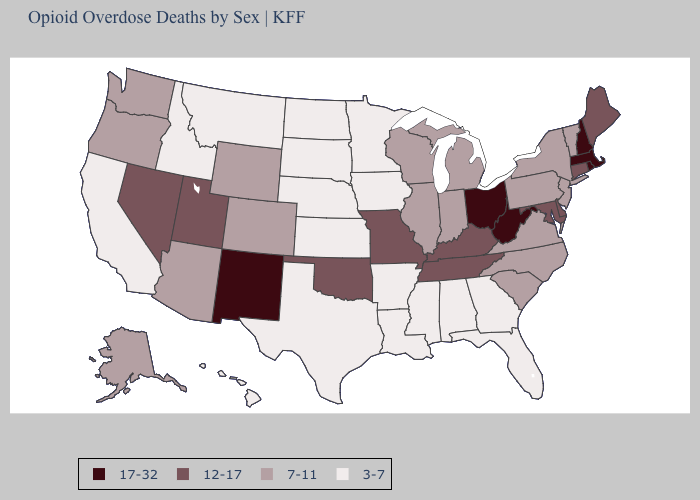Name the states that have a value in the range 17-32?
Write a very short answer. Massachusetts, New Hampshire, New Mexico, Ohio, Rhode Island, West Virginia. Which states have the lowest value in the West?
Be succinct. California, Hawaii, Idaho, Montana. What is the value of Mississippi?
Concise answer only. 3-7. What is the lowest value in states that border Wisconsin?
Keep it brief. 3-7. What is the highest value in the South ?
Write a very short answer. 17-32. Among the states that border Oregon , which have the lowest value?
Keep it brief. California, Idaho. What is the highest value in states that border Delaware?
Short answer required. 12-17. Name the states that have a value in the range 7-11?
Be succinct. Alaska, Arizona, Colorado, Illinois, Indiana, Michigan, New Jersey, New York, North Carolina, Oregon, Pennsylvania, South Carolina, Vermont, Virginia, Washington, Wisconsin, Wyoming. What is the value of Oklahoma?
Keep it brief. 12-17. Does the first symbol in the legend represent the smallest category?
Short answer required. No. Among the states that border Maryland , which have the lowest value?
Answer briefly. Pennsylvania, Virginia. Name the states that have a value in the range 7-11?
Keep it brief. Alaska, Arizona, Colorado, Illinois, Indiana, Michigan, New Jersey, New York, North Carolina, Oregon, Pennsylvania, South Carolina, Vermont, Virginia, Washington, Wisconsin, Wyoming. Among the states that border Indiana , does Illinois have the lowest value?
Short answer required. Yes. Among the states that border Connecticut , does Massachusetts have the highest value?
Keep it brief. Yes. Which states hav the highest value in the MidWest?
Short answer required. Ohio. 